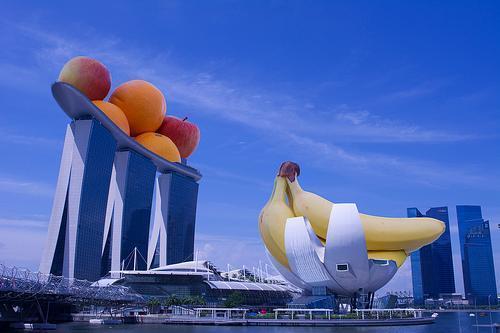How many apples are there?
Give a very brief answer. 2. How many oranges are there?
Give a very brief answer. 3. How many buildings are directly under the apples and oranges?
Give a very brief answer. 3. 